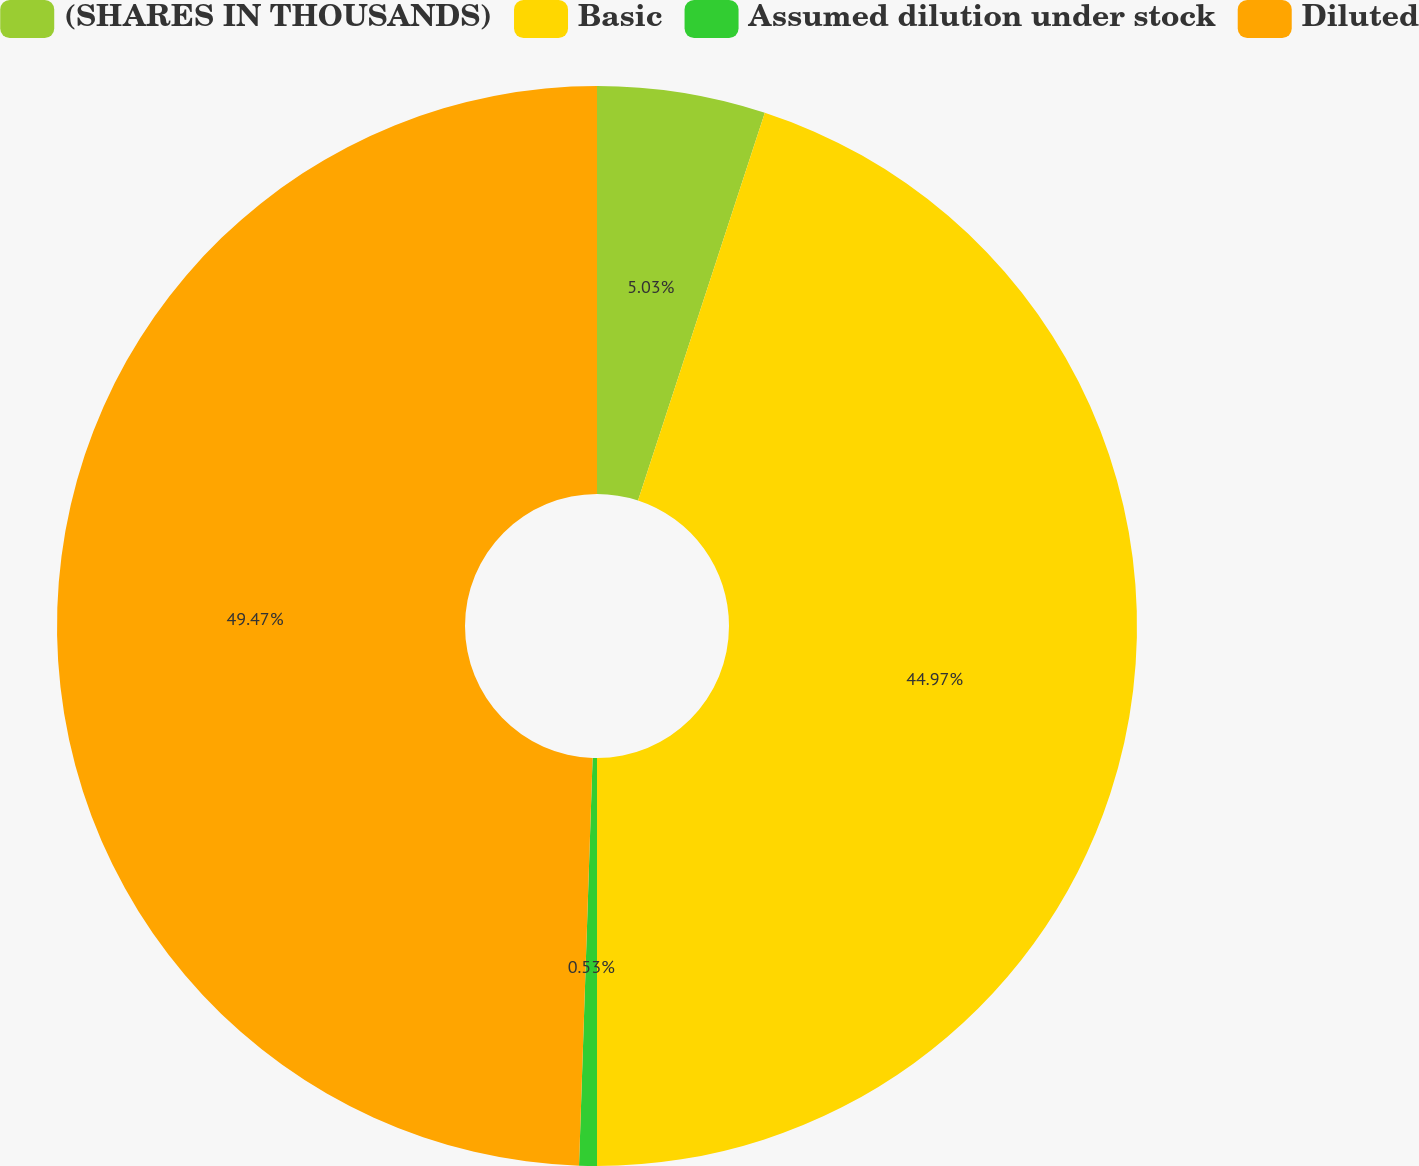Convert chart. <chart><loc_0><loc_0><loc_500><loc_500><pie_chart><fcel>(SHARES IN THOUSANDS)<fcel>Basic<fcel>Assumed dilution under stock<fcel>Diluted<nl><fcel>5.03%<fcel>44.97%<fcel>0.53%<fcel>49.47%<nl></chart> 